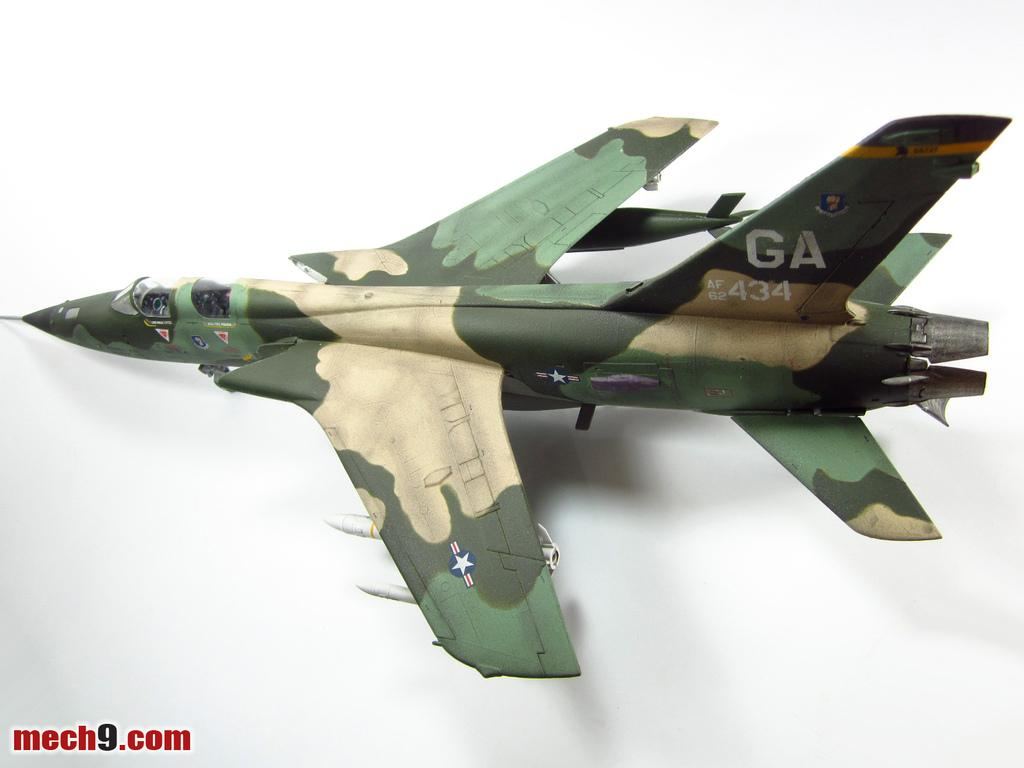<image>
Offer a succinct explanation of the picture presented. A model fighter jet is painted with camouflage and has the tail number GA 434. 